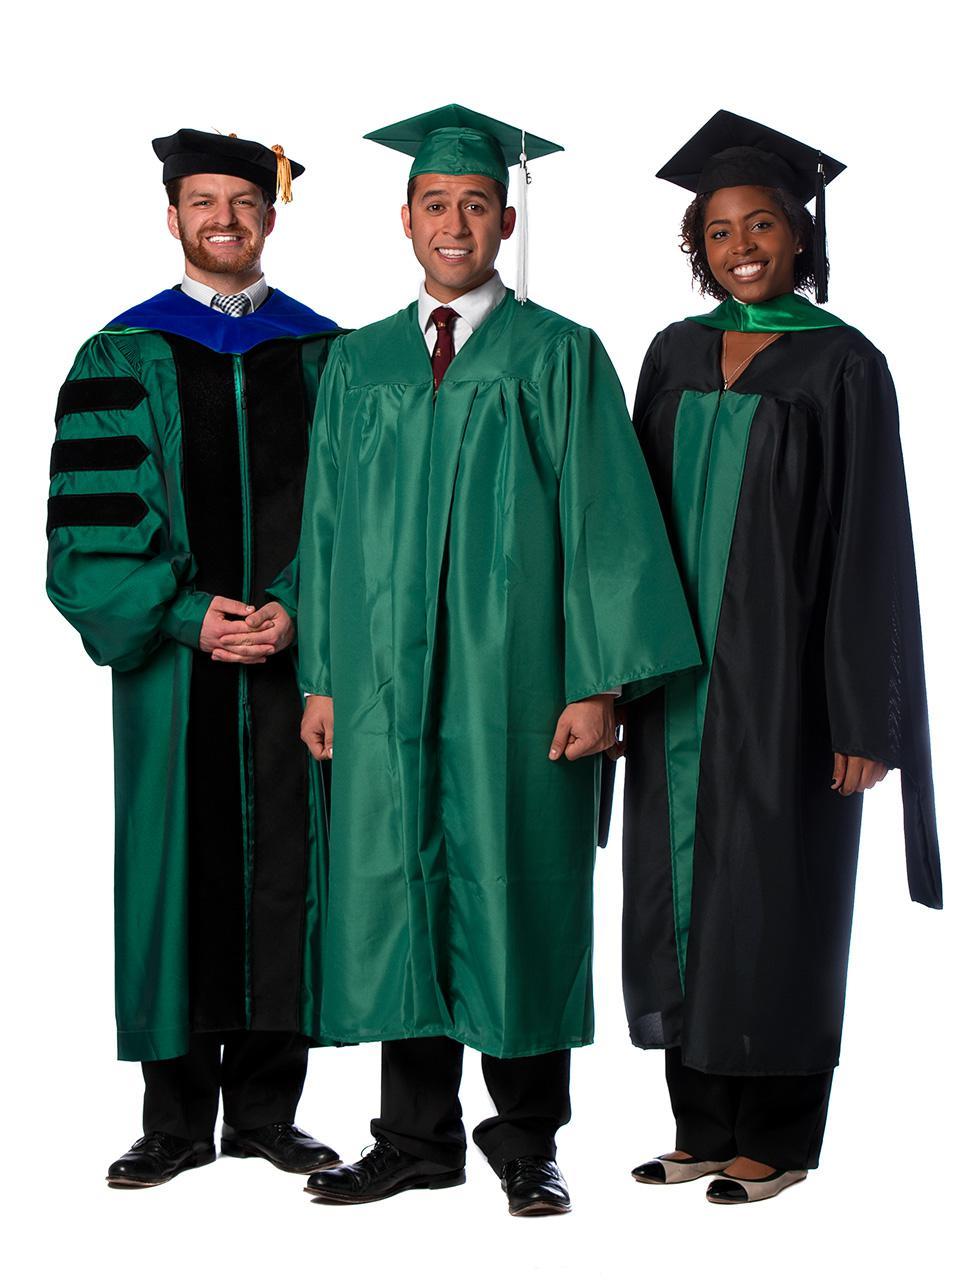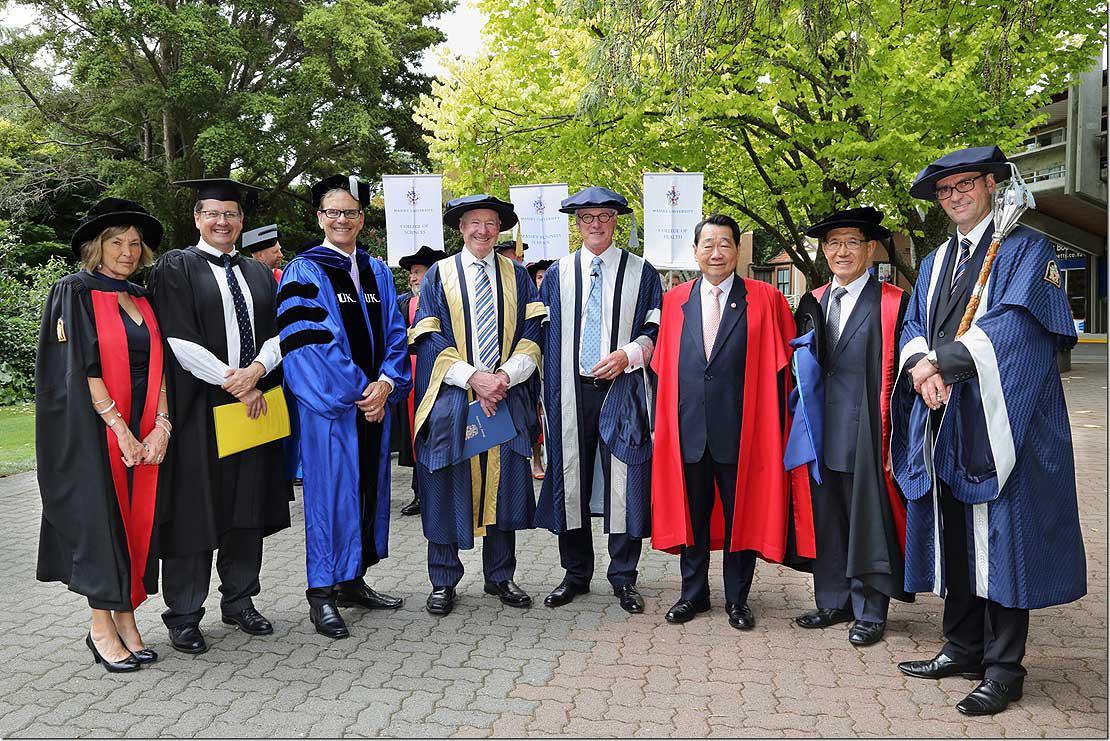The first image is the image on the left, the second image is the image on the right. For the images shown, is this caption "There is at least one graduate wearing a green robe in the image on the left" true? Answer yes or no. Yes. The first image is the image on the left, the second image is the image on the right. Evaluate the accuracy of this statement regarding the images: "There are less than six graduates in one of the images.". Is it true? Answer yes or no. Yes. 